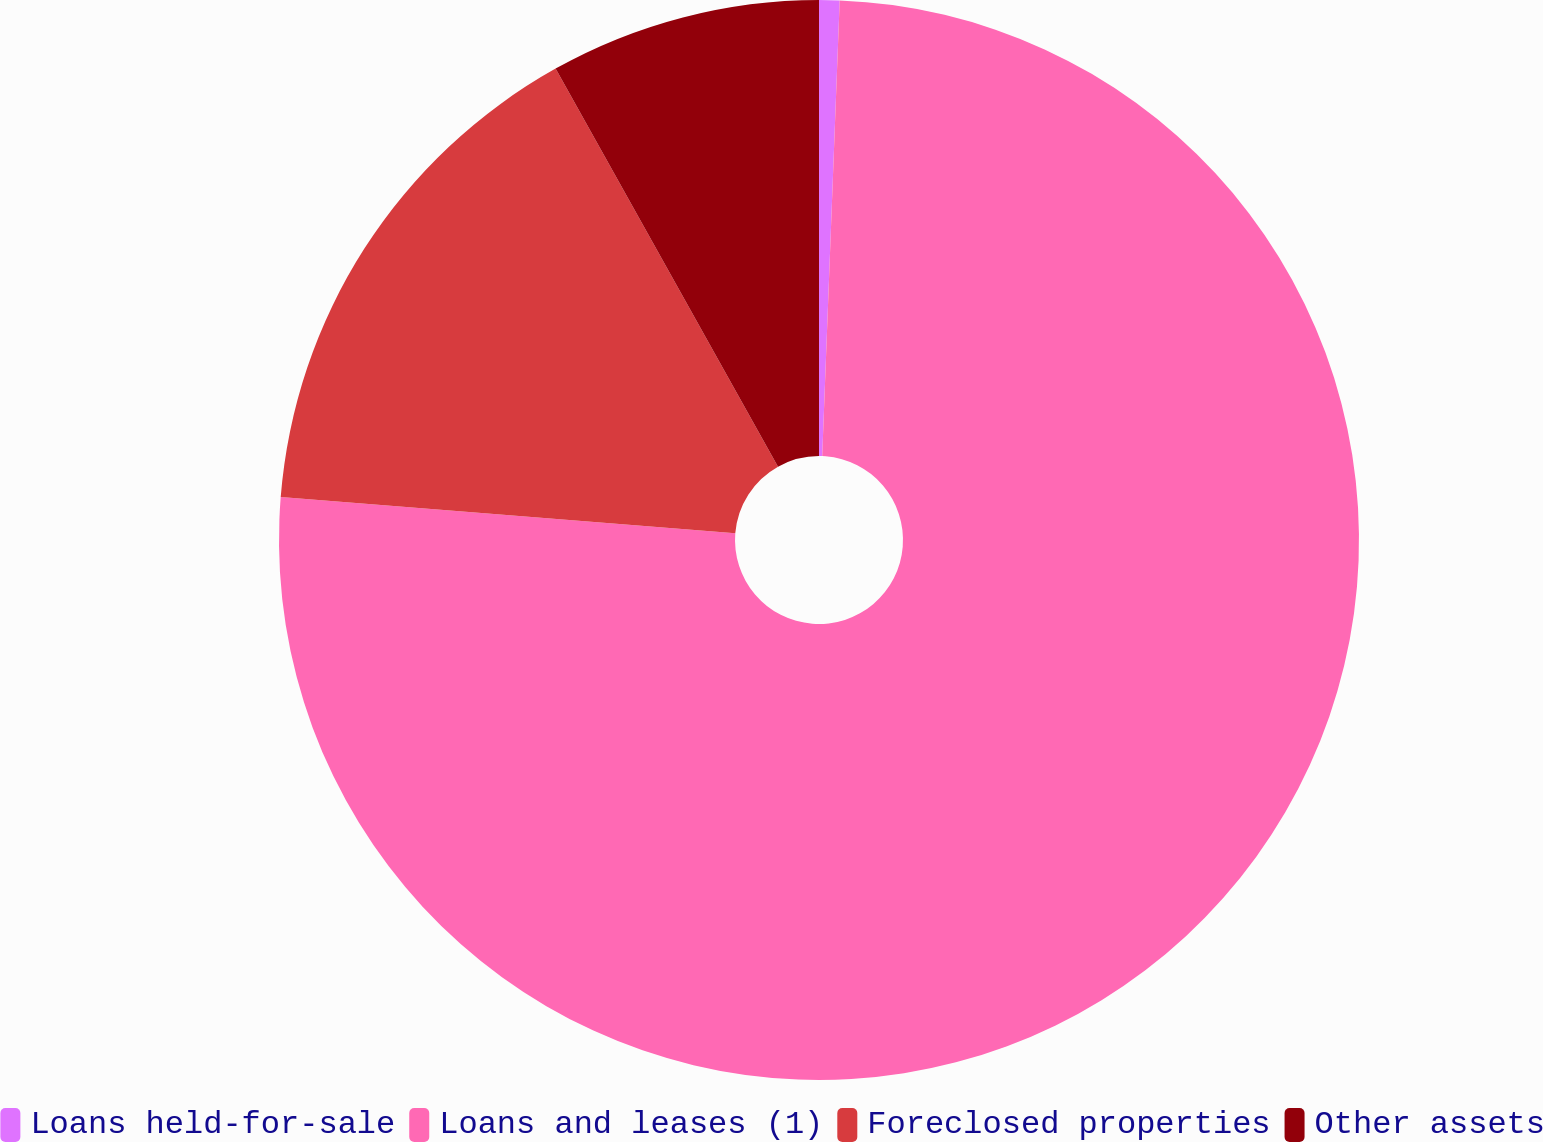<chart> <loc_0><loc_0><loc_500><loc_500><pie_chart><fcel>Loans held-for-sale<fcel>Loans and leases (1)<fcel>Foreclosed properties<fcel>Other assets<nl><fcel>0.61%<fcel>75.66%<fcel>15.62%<fcel>8.11%<nl></chart> 